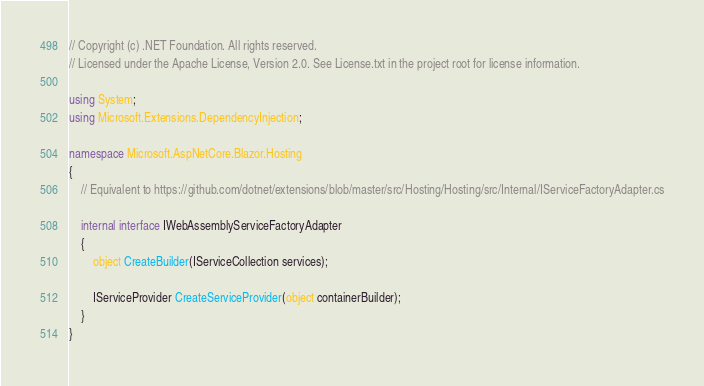Convert code to text. <code><loc_0><loc_0><loc_500><loc_500><_C#_>// Copyright (c) .NET Foundation. All rights reserved.
// Licensed under the Apache License, Version 2.0. See License.txt in the project root for license information.

using System;
using Microsoft.Extensions.DependencyInjection;

namespace Microsoft.AspNetCore.Blazor.Hosting
{
    // Equivalent to https://github.com/dotnet/extensions/blob/master/src/Hosting/Hosting/src/Internal/IServiceFactoryAdapter.cs

    internal interface IWebAssemblyServiceFactoryAdapter
    {
        object CreateBuilder(IServiceCollection services);

        IServiceProvider CreateServiceProvider(object containerBuilder);
    }
}
</code> 